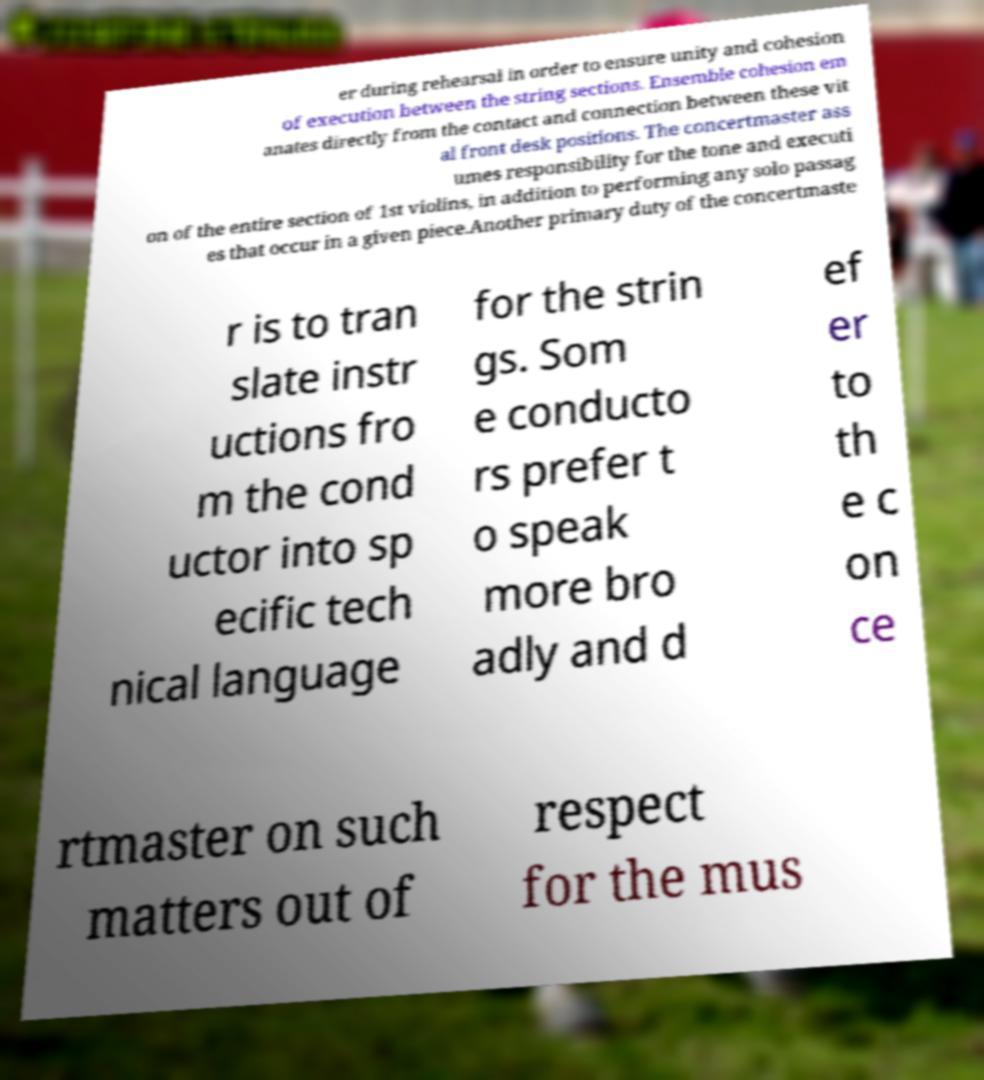For documentation purposes, I need the text within this image transcribed. Could you provide that? er during rehearsal in order to ensure unity and cohesion of execution between the string sections. Ensemble cohesion em anates directly from the contact and connection between these vit al front desk positions. The concertmaster ass umes responsibility for the tone and executi on of the entire section of 1st violins, in addition to performing any solo passag es that occur in a given piece.Another primary duty of the concertmaste r is to tran slate instr uctions fro m the cond uctor into sp ecific tech nical language for the strin gs. Som e conducto rs prefer t o speak more bro adly and d ef er to th e c on ce rtmaster on such matters out of respect for the mus 